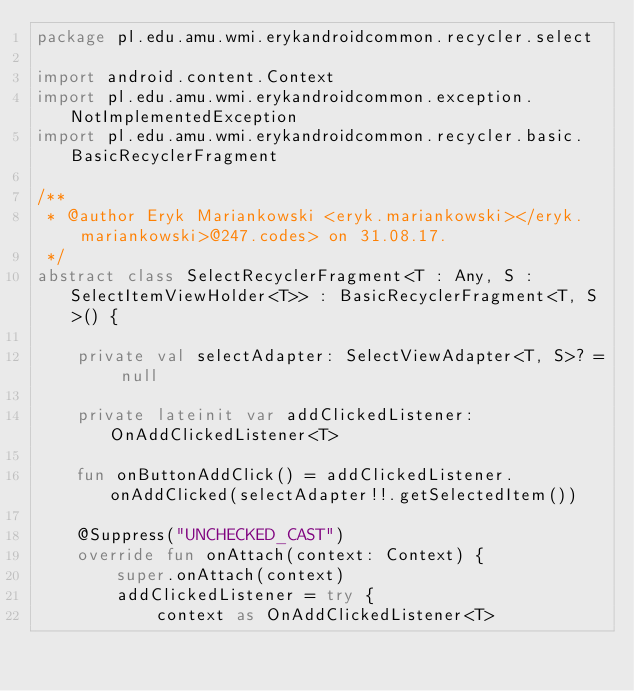<code> <loc_0><loc_0><loc_500><loc_500><_Kotlin_>package pl.edu.amu.wmi.erykandroidcommon.recycler.select

import android.content.Context
import pl.edu.amu.wmi.erykandroidcommon.exception.NotImplementedException
import pl.edu.amu.wmi.erykandroidcommon.recycler.basic.BasicRecyclerFragment

/**
 * @author Eryk Mariankowski <eryk.mariankowski></eryk.mariankowski>@247.codes> on 31.08.17.
 */
abstract class SelectRecyclerFragment<T : Any, S : SelectItemViewHolder<T>> : BasicRecyclerFragment<T, S>() {

    private val selectAdapter: SelectViewAdapter<T, S>? = null

    private lateinit var addClickedListener: OnAddClickedListener<T>

    fun onButtonAddClick() = addClickedListener.onAddClicked(selectAdapter!!.getSelectedItem())

    @Suppress("UNCHECKED_CAST")
    override fun onAttach(context: Context) {
        super.onAttach(context)
        addClickedListener = try {
            context as OnAddClickedListener<T></code> 